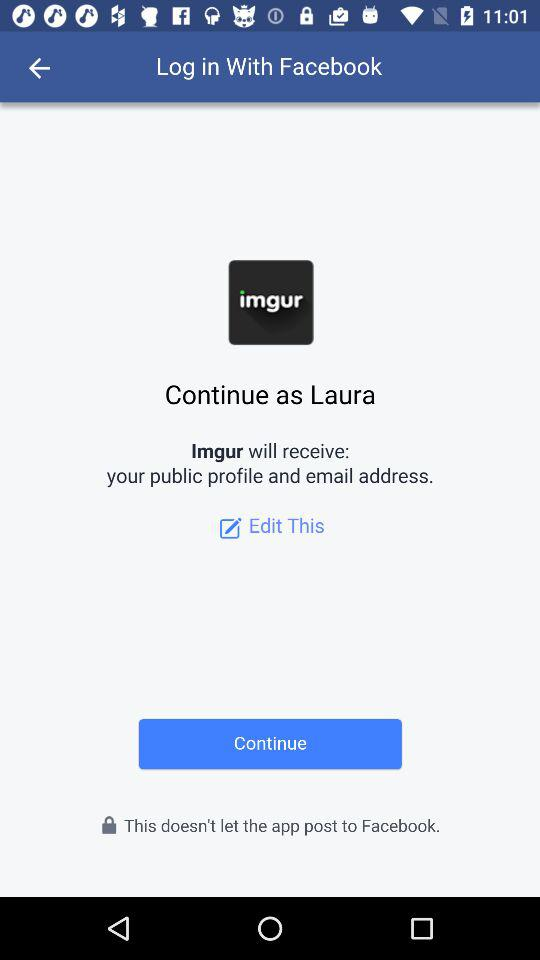What information will Imgur? Imgur will receive a public profile and an email address. 